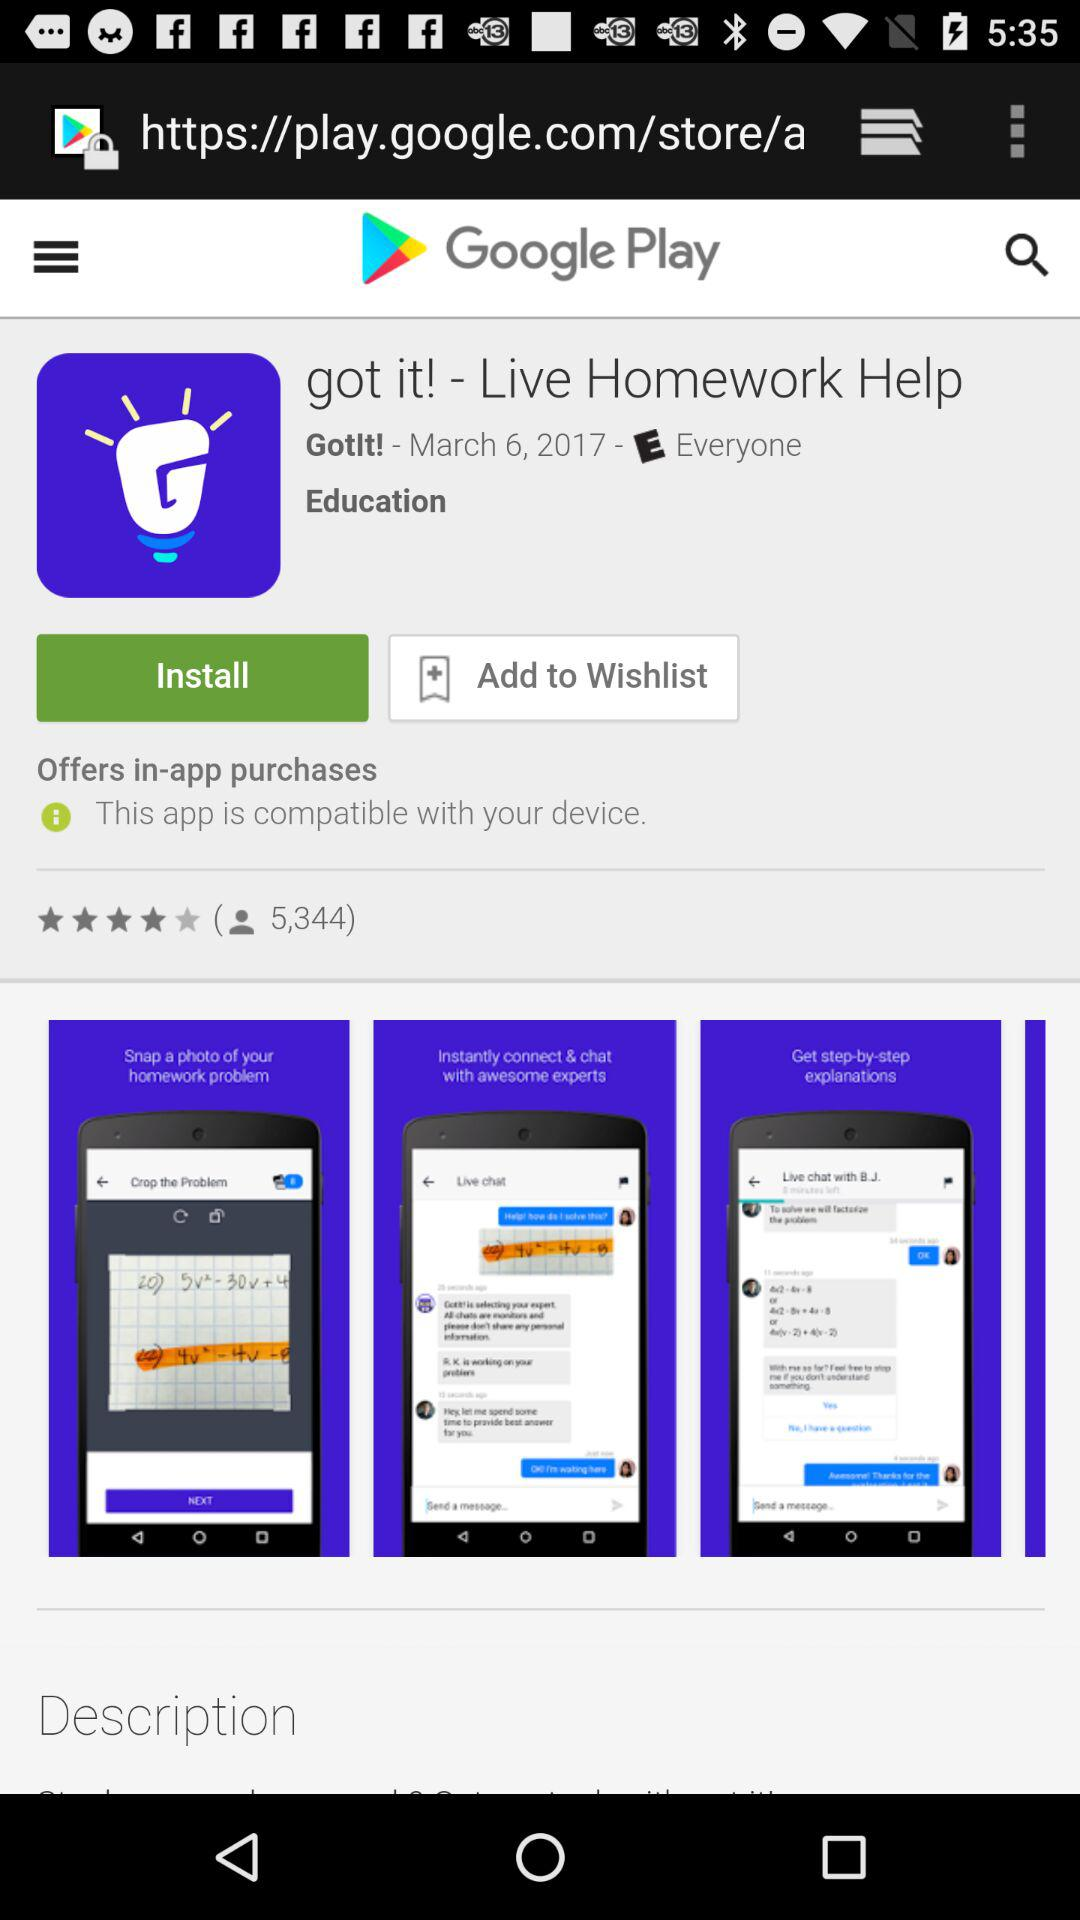What date is shown? The shown date is March 6, 2017. 